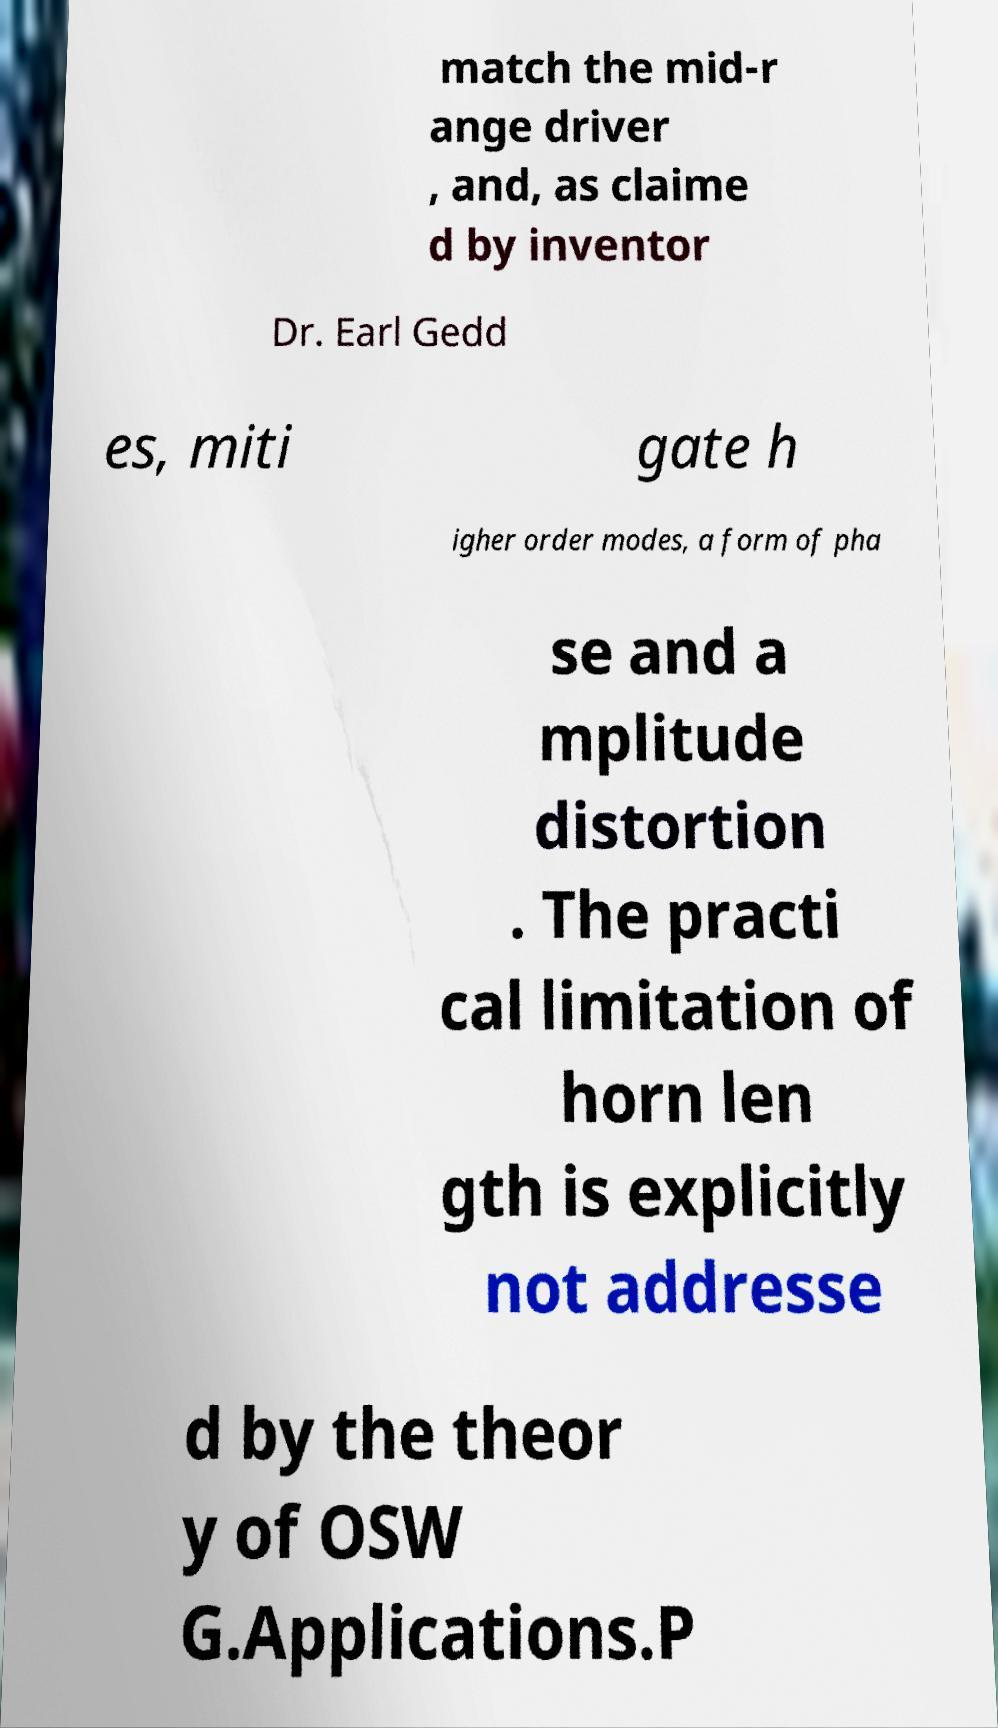What messages or text are displayed in this image? I need them in a readable, typed format. match the mid-r ange driver , and, as claime d by inventor Dr. Earl Gedd es, miti gate h igher order modes, a form of pha se and a mplitude distortion . The practi cal limitation of horn len gth is explicitly not addresse d by the theor y of OSW G.Applications.P 